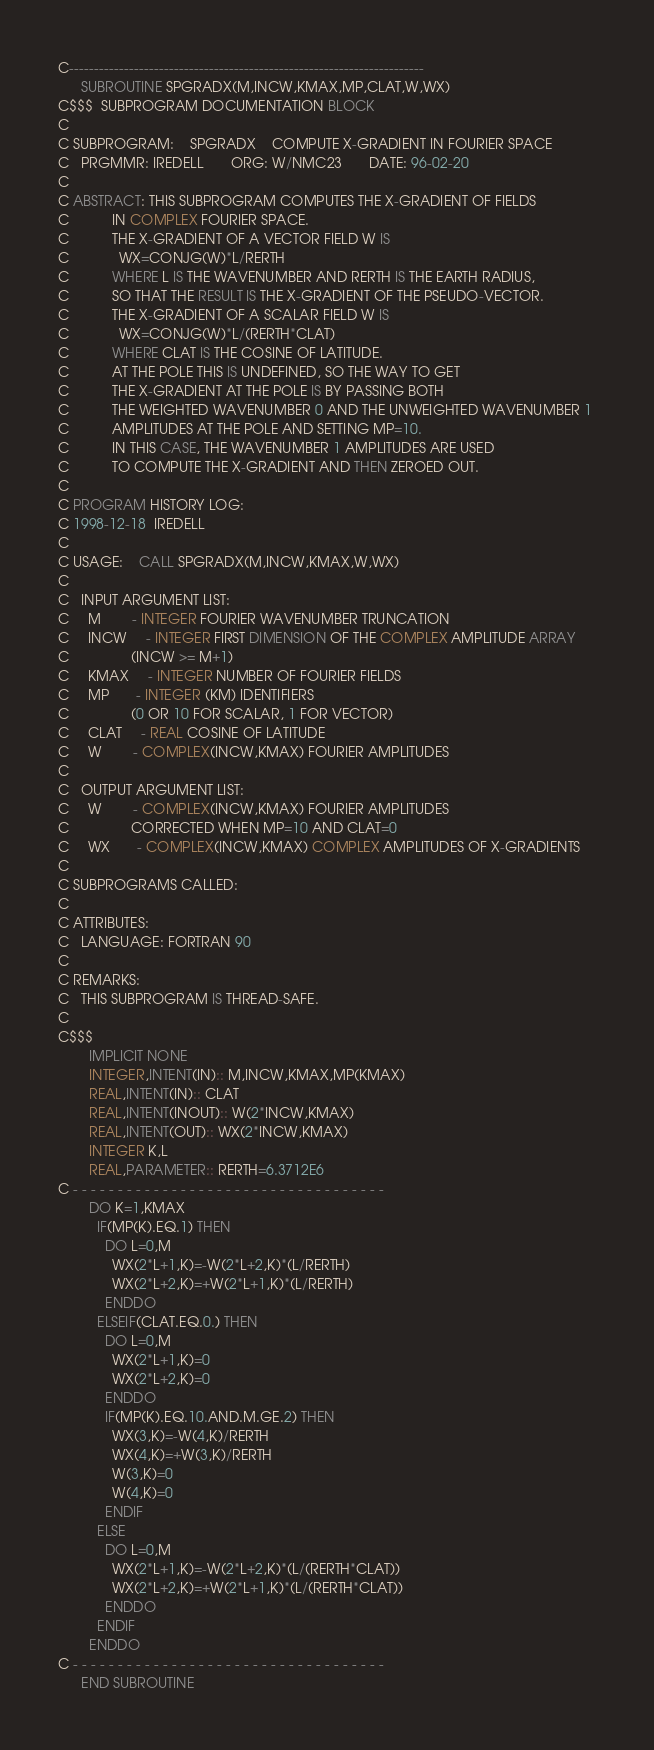Convert code to text. <code><loc_0><loc_0><loc_500><loc_500><_FORTRAN_>C-----------------------------------------------------------------------
      SUBROUTINE SPGRADX(M,INCW,KMAX,MP,CLAT,W,WX)
C$$$  SUBPROGRAM DOCUMENTATION BLOCK
C
C SUBPROGRAM:    SPGRADX    COMPUTE X-GRADIENT IN FOURIER SPACE
C   PRGMMR: IREDELL       ORG: W/NMC23       DATE: 96-02-20
C
C ABSTRACT: THIS SUBPROGRAM COMPUTES THE X-GRADIENT OF FIELDS
C           IN COMPLEX FOURIER SPACE.
C           THE X-GRADIENT OF A VECTOR FIELD W IS
C             WX=CONJG(W)*L/RERTH
C           WHERE L IS THE WAVENUMBER AND RERTH IS THE EARTH RADIUS,
C           SO THAT THE RESULT IS THE X-GRADIENT OF THE PSEUDO-VECTOR.
C           THE X-GRADIENT OF A SCALAR FIELD W IS
C             WX=CONJG(W)*L/(RERTH*CLAT)
C           WHERE CLAT IS THE COSINE OF LATITUDE.
C           AT THE POLE THIS IS UNDEFINED, SO THE WAY TO GET
C           THE X-GRADIENT AT THE POLE IS BY PASSING BOTH
C           THE WEIGHTED WAVENUMBER 0 AND THE UNWEIGHTED WAVENUMBER 1 
C           AMPLITUDES AT THE POLE AND SETTING MP=10.
C           IN THIS CASE, THE WAVENUMBER 1 AMPLITUDES ARE USED
C           TO COMPUTE THE X-GRADIENT AND THEN ZEROED OUT.
C
C PROGRAM HISTORY LOG:
C 1998-12-18  IREDELL
C
C USAGE:    CALL SPGRADX(M,INCW,KMAX,W,WX)
C
C   INPUT ARGUMENT LIST:
C     M        - INTEGER FOURIER WAVENUMBER TRUNCATION
C     INCW     - INTEGER FIRST DIMENSION OF THE COMPLEX AMPLITUDE ARRAY
C                (INCW >= M+1)
C     KMAX     - INTEGER NUMBER OF FOURIER FIELDS
C     MP       - INTEGER (KM) IDENTIFIERS
C                (0 OR 10 FOR SCALAR, 1 FOR VECTOR)
C     CLAT     - REAL COSINE OF LATITUDE
C     W        - COMPLEX(INCW,KMAX) FOURIER AMPLITUDES
C
C   OUTPUT ARGUMENT LIST:
C     W        - COMPLEX(INCW,KMAX) FOURIER AMPLITUDES
C                CORRECTED WHEN MP=10 AND CLAT=0
C     WX       - COMPLEX(INCW,KMAX) COMPLEX AMPLITUDES OF X-GRADIENTS
C
C SUBPROGRAMS CALLED:
C
C ATTRIBUTES:
C   LANGUAGE: FORTRAN 90
C
C REMARKS:
C   THIS SUBPROGRAM IS THREAD-SAFE.
C
C$$$
        IMPLICIT NONE
        INTEGER,INTENT(IN):: M,INCW,KMAX,MP(KMAX)
        REAL,INTENT(IN):: CLAT
        REAL,INTENT(INOUT):: W(2*INCW,KMAX)
        REAL,INTENT(OUT):: WX(2*INCW,KMAX)
        INTEGER K,L
        REAL,PARAMETER:: RERTH=6.3712E6
C - - - - - - - - - - - - - - - - - - - - - - - - - - - - - - - - - - -
        DO K=1,KMAX
          IF(MP(K).EQ.1) THEN
            DO L=0,M
              WX(2*L+1,K)=-W(2*L+2,K)*(L/RERTH)
              WX(2*L+2,K)=+W(2*L+1,K)*(L/RERTH)
            ENDDO
          ELSEIF(CLAT.EQ.0.) THEN
            DO L=0,M
              WX(2*L+1,K)=0
              WX(2*L+2,K)=0
            ENDDO
            IF(MP(K).EQ.10.AND.M.GE.2) THEN
              WX(3,K)=-W(4,K)/RERTH
              WX(4,K)=+W(3,K)/RERTH
              W(3,K)=0
              W(4,K)=0
            ENDIF
          ELSE
            DO L=0,M
              WX(2*L+1,K)=-W(2*L+2,K)*(L/(RERTH*CLAT))
              WX(2*L+2,K)=+W(2*L+1,K)*(L/(RERTH*CLAT))
            ENDDO
          ENDIF
        ENDDO
C - - - - - - - - - - - - - - - - - - - - - - - - - - - - - - - - - - -
      END SUBROUTINE
</code> 